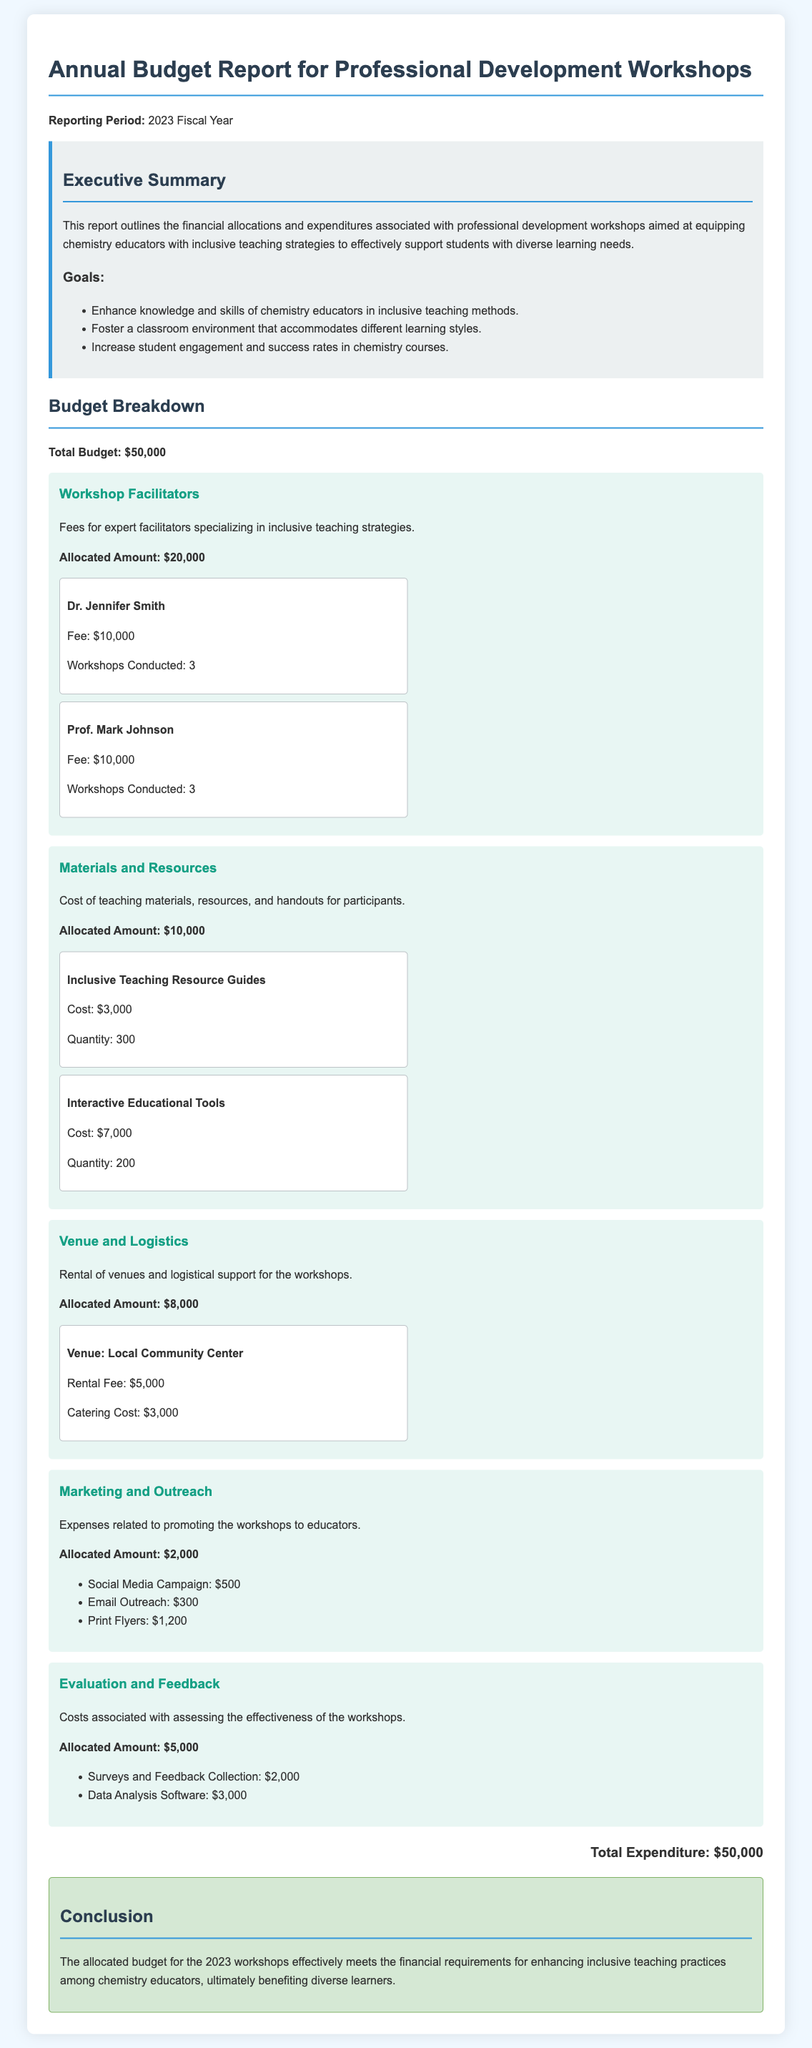What is the total budget? The document states the total budget is outlined as $50,000.
Answer: $50,000 How much is allocated for workshop facilitators? The section dedicated to workshop facilitators specifies an allocated amount of $20,000.
Answer: $20,000 Who facilitated the workshops? The document mentions Dr. Jennifer Smith and Prof. Mark Johnson as facilitators.
Answer: Dr. Jennifer Smith and Prof. Mark Johnson What is the cost of inclusive teaching resource guides? The materials and resources section states that inclusive teaching resource guides cost $3,000.
Answer: $3,000 How much is allocated for evaluation and feedback? The allocation for evaluation and feedback is detailed as $5,000 in the document.
Answer: $5,000 What is the rental fee for the venue? The budget category for venue and logistics indicates a rental fee of $5,000 for the local community center.
Answer: $5,000 What is one of the goals of the workshops? The document lists several goals, one being to enhance knowledge and skills of chemistry educators in inclusive teaching methods.
Answer: Enhance knowledge and skills of chemistry educators in inclusive teaching methods How much was spent on marketing and outreach? The expenses related to marketing and outreach are detailed as $2,000 in the budget section.
Answer: $2,000 What is the total expenditure? The document states that the total expenditure matches the allocated budget of $50,000.
Answer: $50,000 